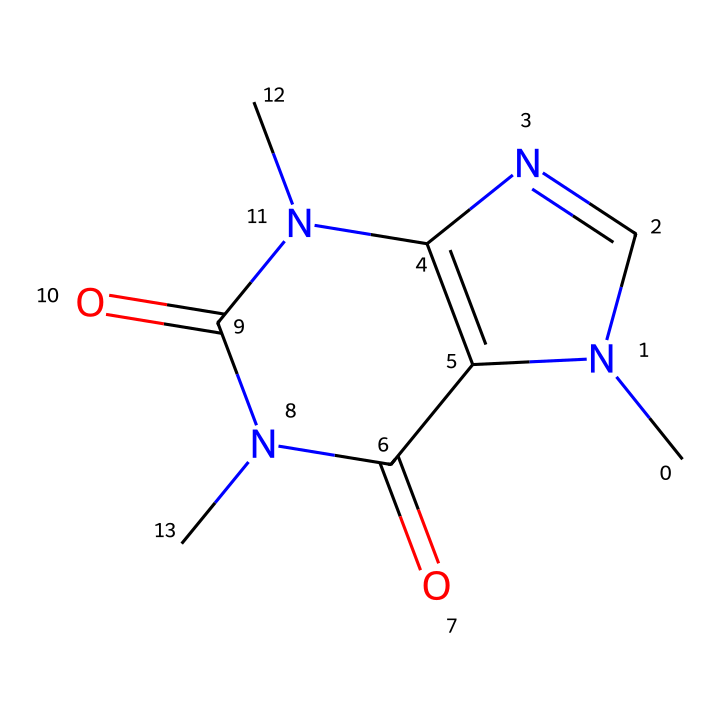What is the total number of nitrogen atoms in this chemical? By examining the SMILES representation, we can identify the nitrogen atoms (N). Counting them yields a total of 4 nitrogen atoms present in the structure.
Answer: 4 How many carbon atoms are in the chemical? The chemical structure can be analyzed by identifying the carbon (C) atoms in the SMILES. Upon counting, there are 7 carbon atoms.
Answer: 7 What type of functional group is present in this chemical? By looking at the chemical structure, we can identify that the presence of carbonyl groups (C=O) indicates that it is an amide considering the context. Thus, it has amide functional groups due to the nitrogen components bonded to carbonyls.
Answer: amide What is the molecular formula of the chemical? To derive the molecular formula, count the number of each type of atom represented: 7 carbons (C), 10 hydrogens (H), 4 nitrogens (N), and 2 oxygens (O). Combining these counts gives the formula C7H10N4O2.
Answer: C7H10N4O2 Does this chemical likely have psychoactive properties? The presence of the nitrogen atoms, in a structure resembling compounds such as taurine and caffeine, suggests that it may exhibit psychoactive properties. Hence, the structural characteristics align with known psychoactive compounds.
Answer: yes 